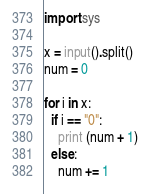<code> <loc_0><loc_0><loc_500><loc_500><_Python_>import sys

x = input().split()
num = 0

for i in x:
  if i == "0":
    print (num + 1)
  else:
    num += 1</code> 